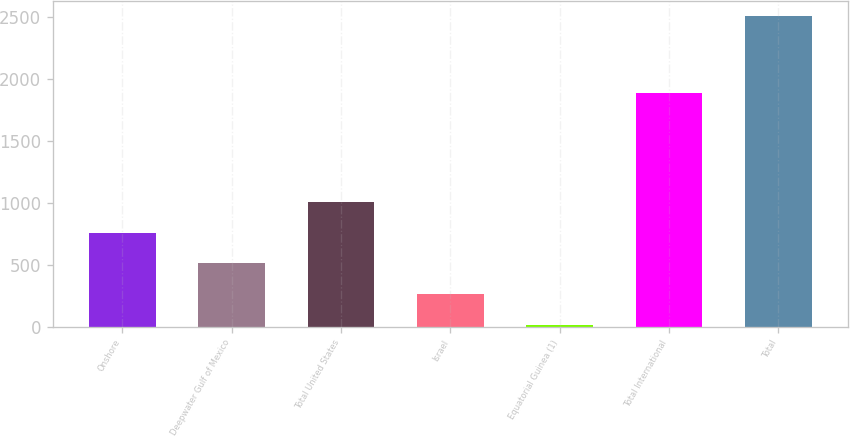Convert chart. <chart><loc_0><loc_0><loc_500><loc_500><bar_chart><fcel>Onshore<fcel>Deepwater Gulf of Mexico<fcel>Total United States<fcel>Israel<fcel>Equatorial Guinea (1)<fcel>Total International<fcel>Total<nl><fcel>759.1<fcel>509.4<fcel>1008.8<fcel>259.7<fcel>10<fcel>1885<fcel>2507<nl></chart> 